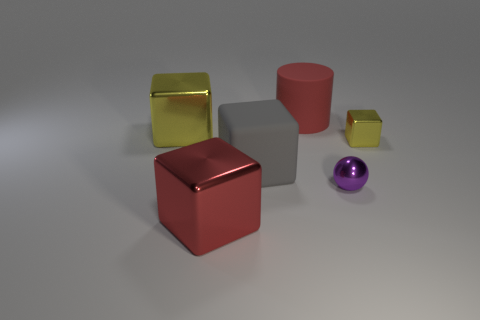What number of big yellow metal things are the same shape as the tiny yellow thing?
Give a very brief answer. 1. Is the material of the yellow thing that is on the left side of the big cylinder the same as the yellow thing on the right side of the large cylinder?
Ensure brevity in your answer.  Yes. There is a yellow thing that is behind the metal block on the right side of the gray rubber cube; how big is it?
Provide a short and direct response. Large. There is a gray object that is the same shape as the red shiny thing; what is its material?
Your response must be concise. Rubber. Is the shape of the big red object in front of the large rubber cylinder the same as the yellow object right of the big matte cylinder?
Provide a short and direct response. Yes. Are there more large blue metallic cylinders than big red cubes?
Provide a short and direct response. No. What is the size of the purple shiny object?
Make the answer very short. Small. What number of other objects are the same color as the tiny cube?
Offer a terse response. 1. Is the material of the yellow thing that is left of the purple metal object the same as the purple ball?
Keep it short and to the point. Yes. Are there fewer purple objects that are left of the red metallic cube than tiny spheres behind the tiny shiny sphere?
Your answer should be very brief. No. 